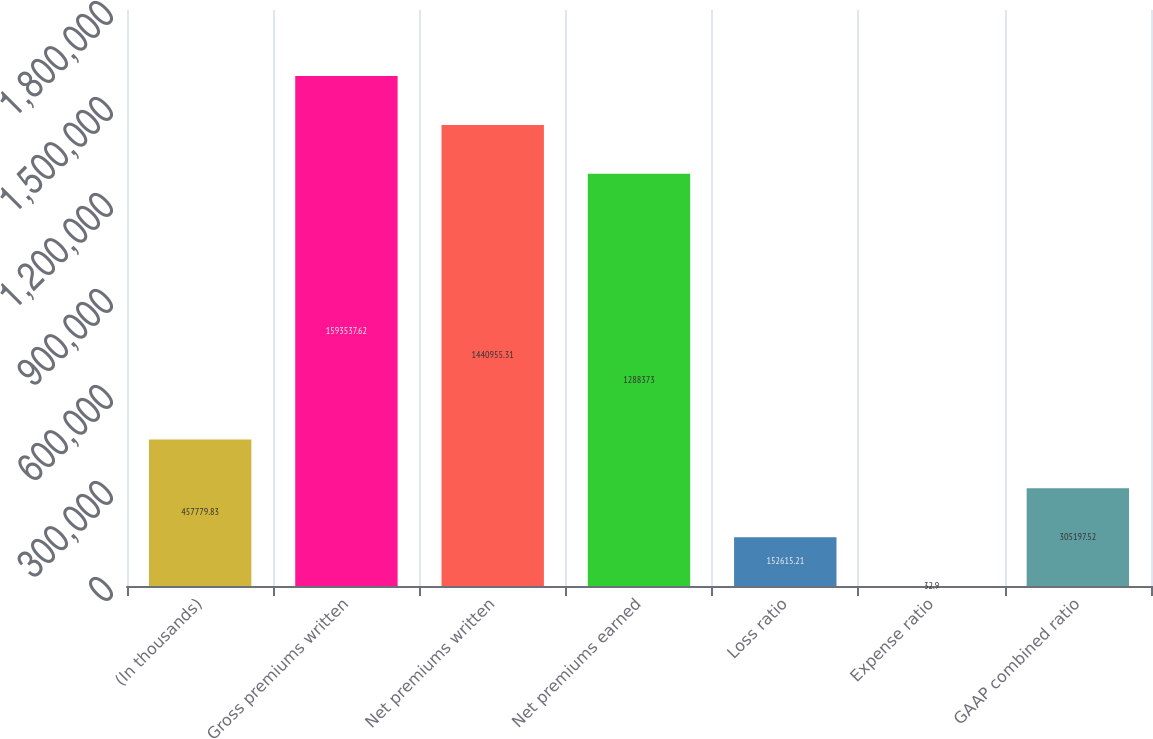Convert chart. <chart><loc_0><loc_0><loc_500><loc_500><bar_chart><fcel>(In thousands)<fcel>Gross premiums written<fcel>Net premiums written<fcel>Net premiums earned<fcel>Loss ratio<fcel>Expense ratio<fcel>GAAP combined ratio<nl><fcel>457780<fcel>1.59354e+06<fcel>1.44096e+06<fcel>1.28837e+06<fcel>152615<fcel>32.9<fcel>305198<nl></chart> 